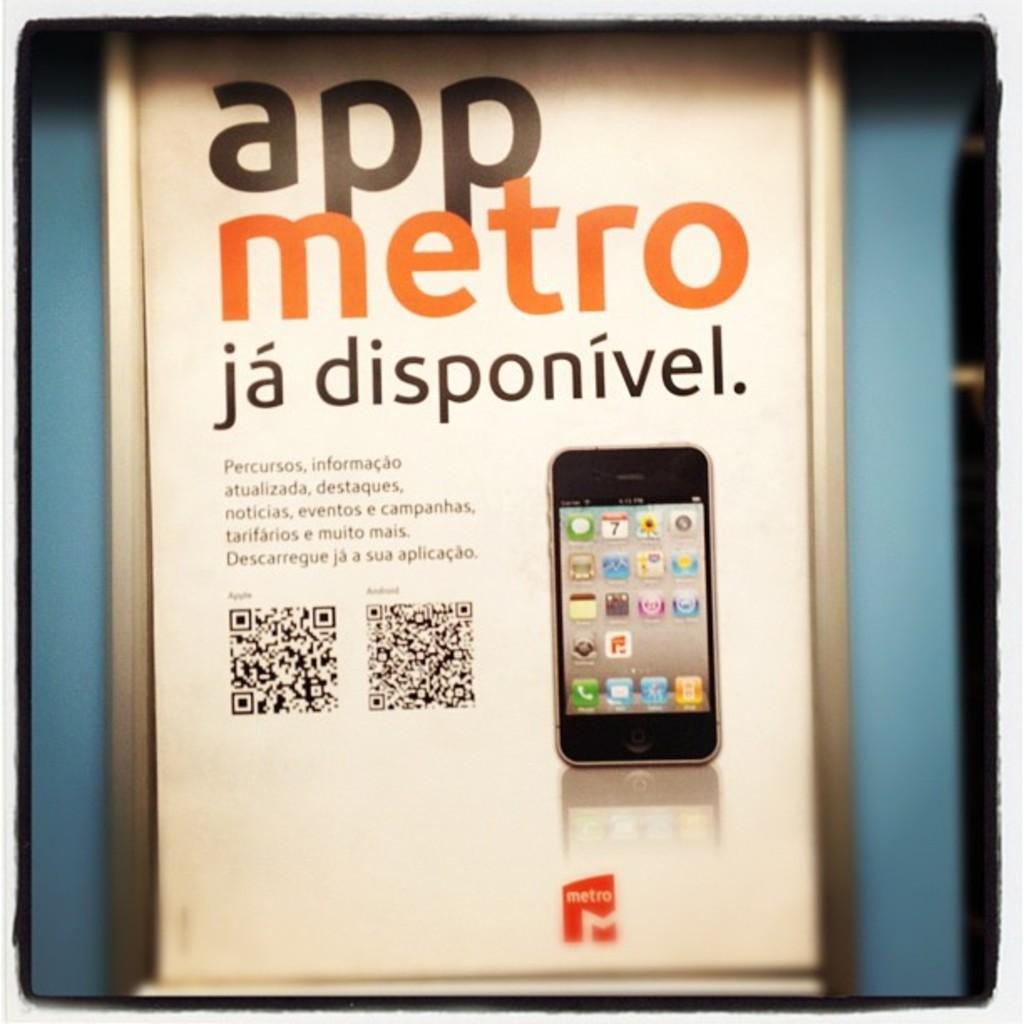What app is being advertised?
Offer a terse response. App metro. 